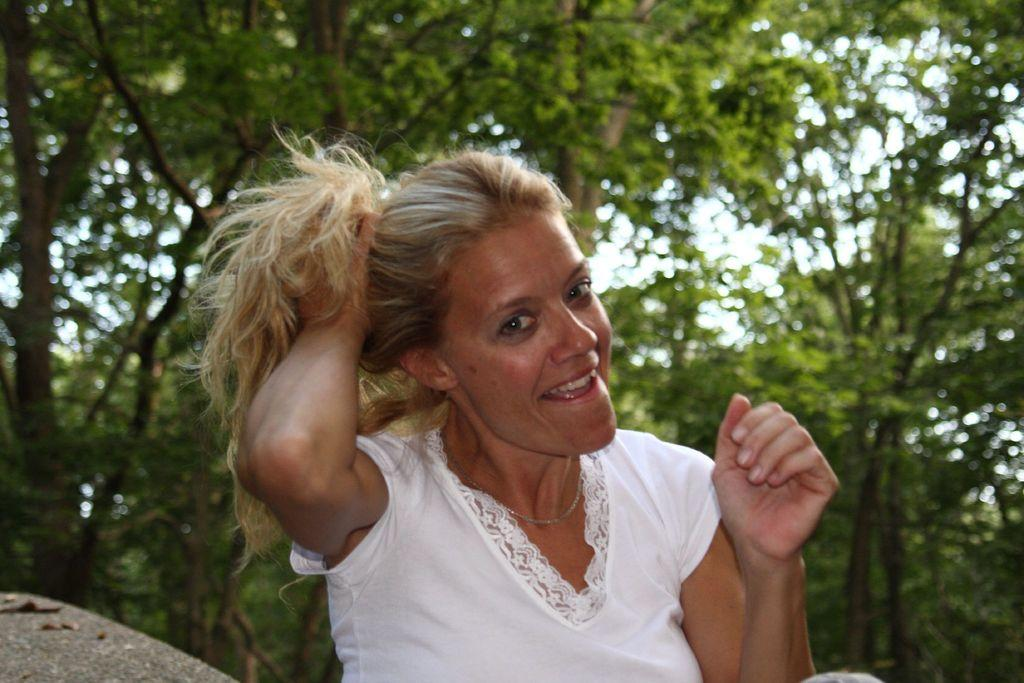What is the main subject of the image? The main subject of the image is a woman. What is the woman wearing in the image? The woman is wearing a white top in the image. What is the woman doing with her hair in the image? The woman is holding her hair with her hand in the image. What is the woman's facial expression in the image? The woman is smiling in the image. What is the woman doing in the image? The woman is giving a pose for the photograph in the image. What can be seen in the background of the image? There are trees visible in the background of the image. What type of sign can be seen in the image? There is no sign present in the image. What detail about the woman's hair can be seen in the image? The woman is holding her hair with her hand in the image, but there is no specific detail about her hair that can be seen. 